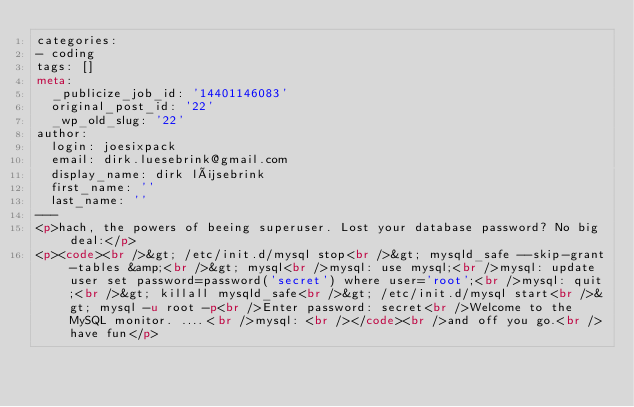Convert code to text. <code><loc_0><loc_0><loc_500><loc_500><_HTML_>categories:
- coding
tags: []
meta:
  _publicize_job_id: '14401146083'
  original_post_id: '22'
  _wp_old_slug: '22'
author:
  login: joesixpack
  email: dirk.luesebrink@gmail.com
  display_name: dirk lüsebrink
  first_name: ''
  last_name: ''
---
<p>hach, the powers of beeing superuser. Lost your database password? No big deal:</p>
<p><code><br />&gt; /etc/init.d/mysql stop<br />&gt; mysqld_safe --skip-grant-tables &amp;<br />&gt; mysql<br />mysql: use mysql;<br />mysql: update user set password=password('secret') where user='root';<br />mysql: quit;<br />&gt; killall mysqld_safe<br />&gt; /etc/init.d/mysql start<br />&gt; mysql -u root -p<br />Enter password: secret<br />Welcome to the MySQL monitor. ....<br />mysql: <br /></code><br />and off you go.<br />have fun</p>
</code> 